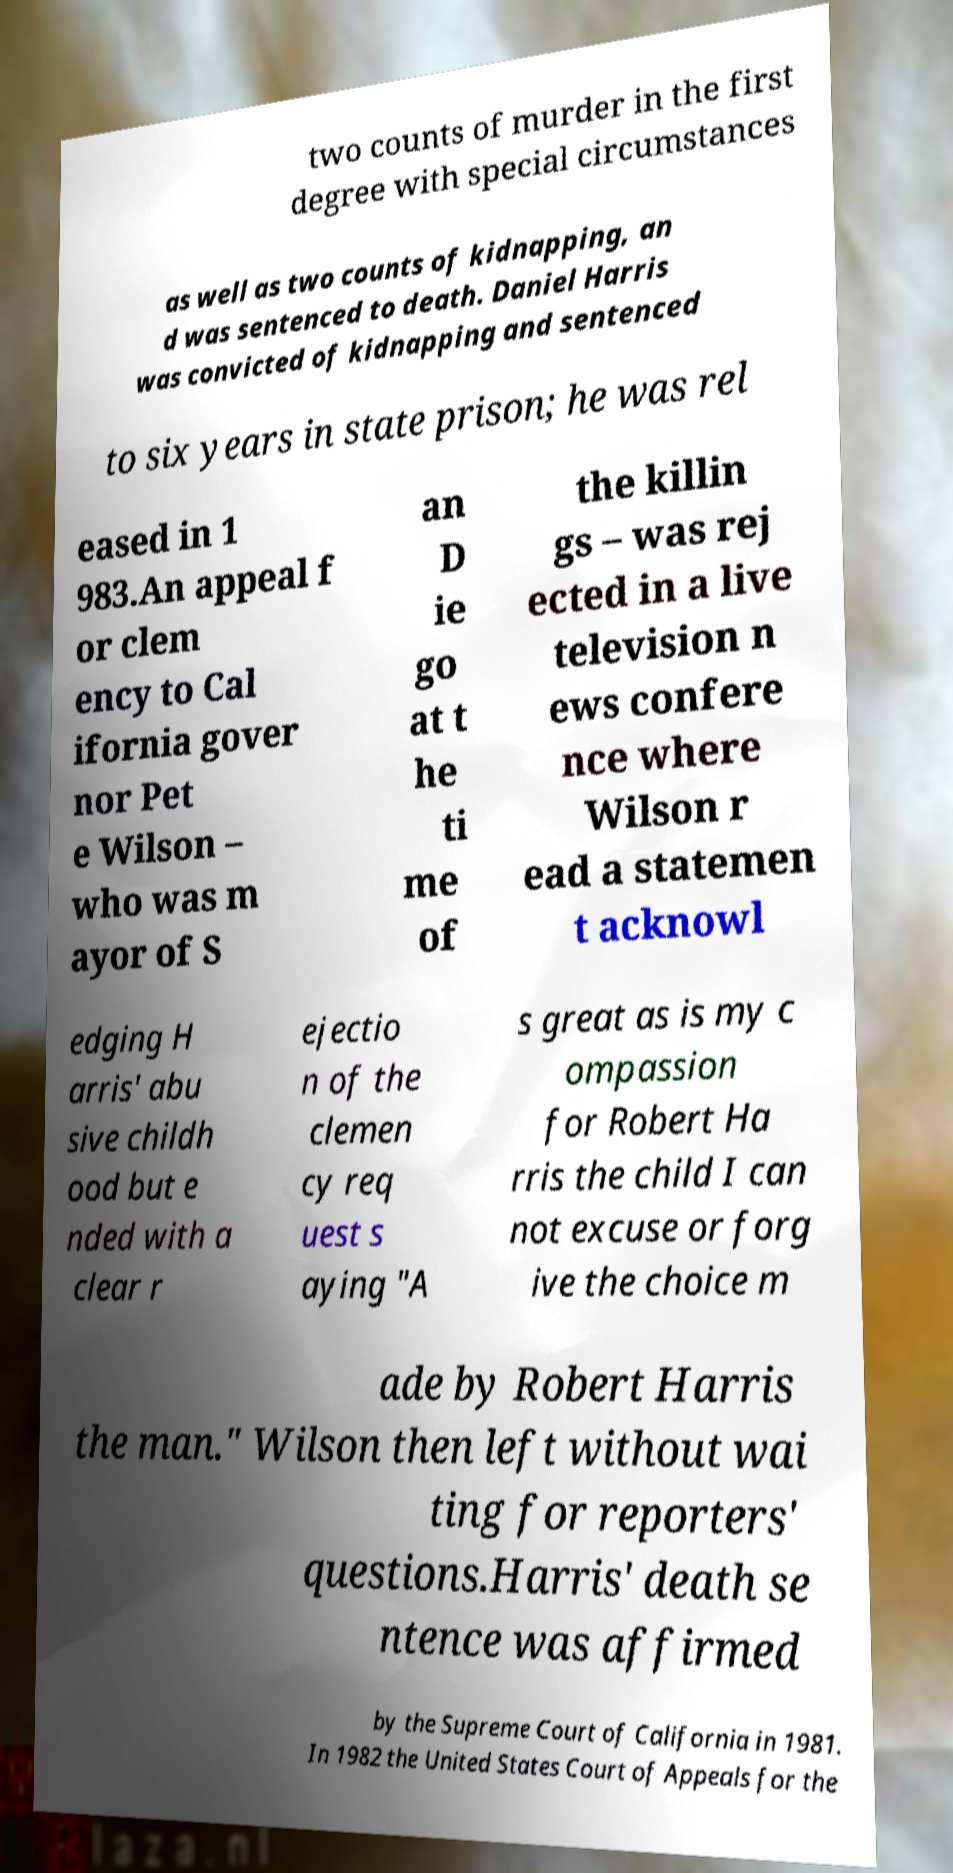Could you assist in decoding the text presented in this image and type it out clearly? two counts of murder in the first degree with special circumstances as well as two counts of kidnapping, an d was sentenced to death. Daniel Harris was convicted of kidnapping and sentenced to six years in state prison; he was rel eased in 1 983.An appeal f or clem ency to Cal ifornia gover nor Pet e Wilson – who was m ayor of S an D ie go at t he ti me of the killin gs – was rej ected in a live television n ews confere nce where Wilson r ead a statemen t acknowl edging H arris' abu sive childh ood but e nded with a clear r ejectio n of the clemen cy req uest s aying "A s great as is my c ompassion for Robert Ha rris the child I can not excuse or forg ive the choice m ade by Robert Harris the man." Wilson then left without wai ting for reporters' questions.Harris' death se ntence was affirmed by the Supreme Court of California in 1981. In 1982 the United States Court of Appeals for the 